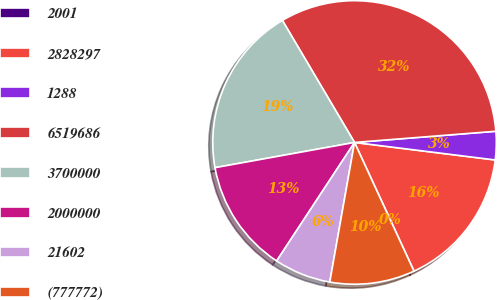Convert chart to OTSL. <chart><loc_0><loc_0><loc_500><loc_500><pie_chart><fcel>2001<fcel>2828297<fcel>1288<fcel>6519686<fcel>3700000<fcel>2000000<fcel>21602<fcel>(777772)<nl><fcel>0.01%<fcel>16.13%<fcel>3.23%<fcel>32.24%<fcel>19.35%<fcel>12.9%<fcel>6.46%<fcel>9.68%<nl></chart> 